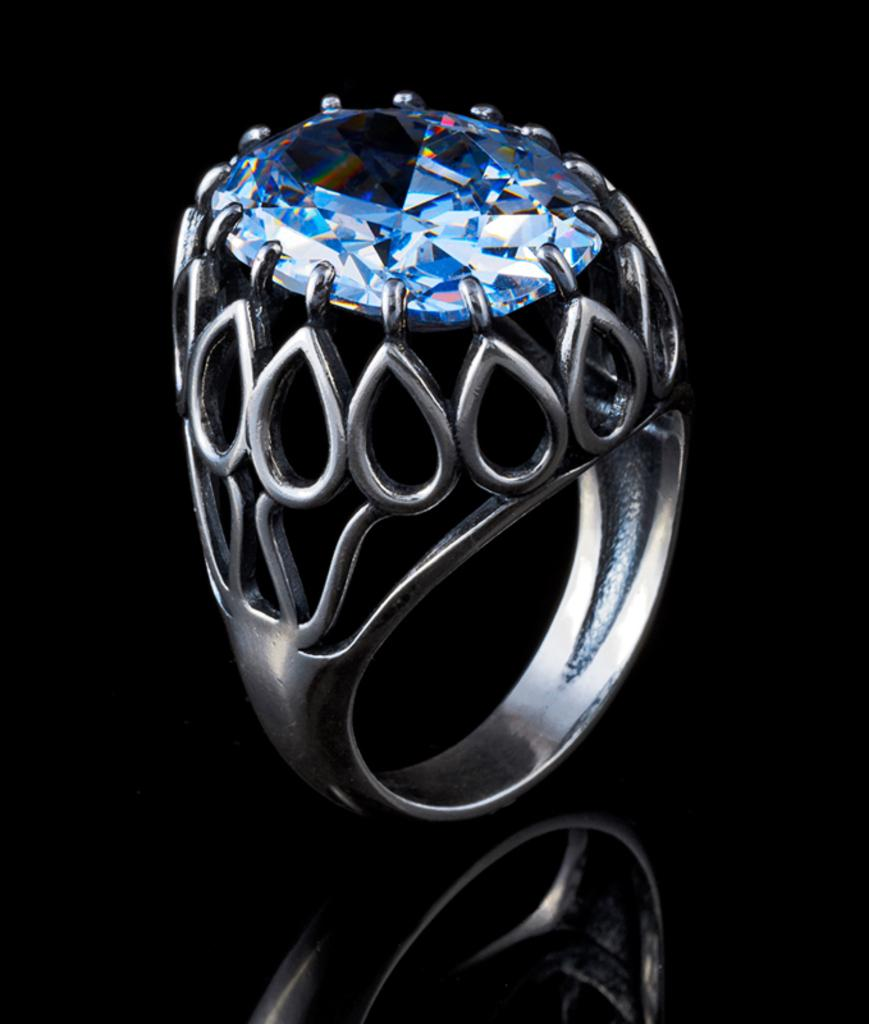What is the main object in the image? There is a ring in the image. What is the color of the stone in the ring? The stone in the ring is blue. How does the blue stone resemble a diamond? The blue stone resembles a diamond in terms of its shape and sparkle. What is the color of the background in the image? The background of the image is dark. What type of pig can be seen in the image? There is no pig present in the image; it features a ring with a blue stone that resembles a diamond. What type of iron is used to create the ring in the image? The facts provided do not mention the material used to create the ring, so it cannot be determined from the image. 